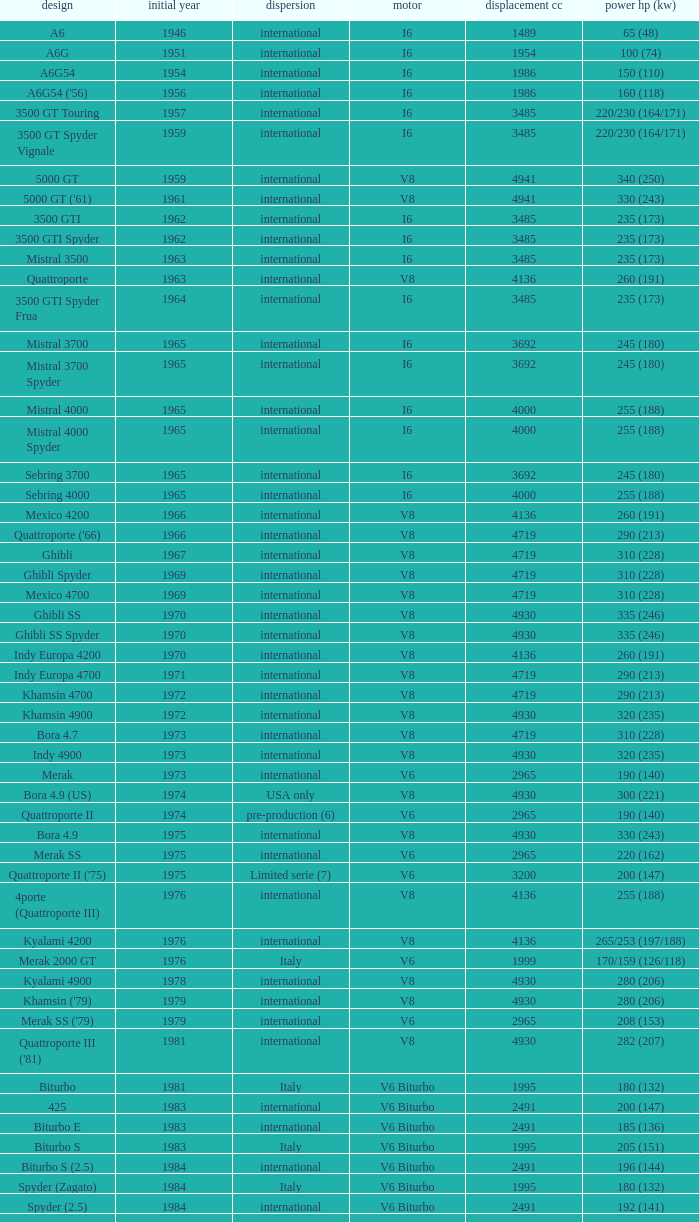Can you parse all the data within this table? {'header': ['design', 'initial year', 'dispersion', 'motor', 'displacement cc', 'power hp (kw)'], 'rows': [['A6', '1946', 'international', 'I6', '1489', '65 (48)'], ['A6G', '1951', 'international', 'I6', '1954', '100 (74)'], ['A6G54', '1954', 'international', 'I6', '1986', '150 (110)'], ["A6G54 ('56)", '1956', 'international', 'I6', '1986', '160 (118)'], ['3500 GT Touring', '1957', 'international', 'I6', '3485', '220/230 (164/171)'], ['3500 GT Spyder Vignale', '1959', 'international', 'I6', '3485', '220/230 (164/171)'], ['5000 GT', '1959', 'international', 'V8', '4941', '340 (250)'], ["5000 GT ('61)", '1961', 'international', 'V8', '4941', '330 (243)'], ['3500 GTI', '1962', 'international', 'I6', '3485', '235 (173)'], ['3500 GTI Spyder', '1962', 'international', 'I6', '3485', '235 (173)'], ['Mistral 3500', '1963', 'international', 'I6', '3485', '235 (173)'], ['Quattroporte', '1963', 'international', 'V8', '4136', '260 (191)'], ['3500 GTI Spyder Frua', '1964', 'international', 'I6', '3485', '235 (173)'], ['Mistral 3700', '1965', 'international', 'I6', '3692', '245 (180)'], ['Mistral 3700 Spyder', '1965', 'international', 'I6', '3692', '245 (180)'], ['Mistral 4000', '1965', 'international', 'I6', '4000', '255 (188)'], ['Mistral 4000 Spyder', '1965', 'international', 'I6', '4000', '255 (188)'], ['Sebring 3700', '1965', 'international', 'I6', '3692', '245 (180)'], ['Sebring 4000', '1965', 'international', 'I6', '4000', '255 (188)'], ['Mexico 4200', '1966', 'international', 'V8', '4136', '260 (191)'], ["Quattroporte ('66)", '1966', 'international', 'V8', '4719', '290 (213)'], ['Ghibli', '1967', 'international', 'V8', '4719', '310 (228)'], ['Ghibli Spyder', '1969', 'international', 'V8', '4719', '310 (228)'], ['Mexico 4700', '1969', 'international', 'V8', '4719', '310 (228)'], ['Ghibli SS', '1970', 'international', 'V8', '4930', '335 (246)'], ['Ghibli SS Spyder', '1970', 'international', 'V8', '4930', '335 (246)'], ['Indy Europa 4200', '1970', 'international', 'V8', '4136', '260 (191)'], ['Indy Europa 4700', '1971', 'international', 'V8', '4719', '290 (213)'], ['Khamsin 4700', '1972', 'international', 'V8', '4719', '290 (213)'], ['Khamsin 4900', '1972', 'international', 'V8', '4930', '320 (235)'], ['Bora 4.7', '1973', 'international', 'V8', '4719', '310 (228)'], ['Indy 4900', '1973', 'international', 'V8', '4930', '320 (235)'], ['Merak', '1973', 'international', 'V6', '2965', '190 (140)'], ['Bora 4.9 (US)', '1974', 'USA only', 'V8', '4930', '300 (221)'], ['Quattroporte II', '1974', 'pre-production (6)', 'V6', '2965', '190 (140)'], ['Bora 4.9', '1975', 'international', 'V8', '4930', '330 (243)'], ['Merak SS', '1975', 'international', 'V6', '2965', '220 (162)'], ["Quattroporte II ('75)", '1975', 'Limited serie (7)', 'V6', '3200', '200 (147)'], ['4porte (Quattroporte III)', '1976', 'international', 'V8', '4136', '255 (188)'], ['Kyalami 4200', '1976', 'international', 'V8', '4136', '265/253 (197/188)'], ['Merak 2000 GT', '1976', 'Italy', 'V6', '1999', '170/159 (126/118)'], ['Kyalami 4900', '1978', 'international', 'V8', '4930', '280 (206)'], ["Khamsin ('79)", '1979', 'international', 'V8', '4930', '280 (206)'], ["Merak SS ('79)", '1979', 'international', 'V6', '2965', '208 (153)'], ["Quattroporte III ('81)", '1981', 'international', 'V8', '4930', '282 (207)'], ['Biturbo', '1981', 'Italy', 'V6 Biturbo', '1995', '180 (132)'], ['425', '1983', 'international', 'V6 Biturbo', '2491', '200 (147)'], ['Biturbo E', '1983', 'international', 'V6 Biturbo', '2491', '185 (136)'], ['Biturbo S', '1983', 'Italy', 'V6 Biturbo', '1995', '205 (151)'], ['Biturbo S (2.5)', '1984', 'international', 'V6 Biturbo', '2491', '196 (144)'], ['Spyder (Zagato)', '1984', 'Italy', 'V6 Biturbo', '1995', '180 (132)'], ['Spyder (2.5)', '1984', 'international', 'V6 Biturbo', '2491', '192 (141)'], ['420', '1985', 'Italy', 'V6 Biturbo', '1995', '180 (132)'], ['Biturbo (II)', '1985', 'Italy', 'V6 Biturbo', '1995', '180 (132)'], ['Biturbo E (II 2.5)', '1985', 'international', 'V6 Biturbo', '2491', '185 (136)'], ['Biturbo S (II)', '1985', 'Italy', 'V6 Biturbo', '1995', '210 (154)'], ['228 (228i)', '1986', 'international', 'V6 Biturbo', '2790', '250 (184)'], ['228 (228i) Kat', '1986', 'international', 'V6 Biturbo', '2790', '225 (165)'], ['420i', '1986', 'Italy', 'V6 Biturbo', '1995', '190 (140)'], ['420 S', '1986', 'Italy', 'V6 Biturbo', '1995', '210 (154)'], ['Biturbo i', '1986', 'Italy', 'V6 Biturbo', '1995', '185 (136)'], ['Quattroporte Royale (III)', '1986', 'international', 'V8', '4930', '300 (221)'], ['Spyder i', '1986', 'international', 'V6 Biturbo', '1996', '185 (136)'], ['430', '1987', 'international', 'V6 Biturbo', '2790', '225 (165)'], ['425i', '1987', 'international', 'V6 Biturbo', '2491', '188 (138)'], ['Biturbo Si', '1987', 'Italy', 'V6 Biturbo', '1995', '220 (162)'], ['Biturbo Si (2.5)', '1987', 'international', 'V6 Biturbo', '2491', '188 (138)'], ["Spyder i ('87)", '1987', 'international', 'V6 Biturbo', '1996', '195 (143)'], ['222', '1988', 'Italy', 'V6 Biturbo', '1996', '220 (162)'], ['422', '1988', 'Italy', 'V6 Biturbo', '1996', '220 (162)'], ['2.24V', '1988', 'Italy (probably)', 'V6 Biturbo', '1996', '245 (180)'], ['222 4v', '1988', 'international', 'V6 Biturbo', '2790', '279 (205)'], ['222 E', '1988', 'international', 'V6 Biturbo', '2790', '225 (165)'], ['Karif', '1988', 'international', 'V6 Biturbo', '2790', '285 (210)'], ['Karif (kat)', '1988', 'international', 'V6 Biturbo', '2790', '248 (182)'], ['Karif (kat II)', '1988', 'international', 'V6 Biturbo', '2790', '225 (165)'], ['Spyder i (2.5)', '1988', 'international', 'V6 Biturbo', '2491', '188 (138)'], ['Spyder i (2.8)', '1989', 'international', 'V6 Biturbo', '2790', '250 (184)'], ['Spyder i (2.8, kat)', '1989', 'international', 'V6 Biturbo', '2790', '225 (165)'], ["Spyder i ('90)", '1989', 'Italy', 'V6 Biturbo', '1996', '220 (162)'], ['222 SE', '1990', 'international', 'V6 Biturbo', '2790', '250 (184)'], ['222 SE (kat)', '1990', 'international', 'V6 Biturbo', '2790', '225 (165)'], ['4.18v', '1990', 'Italy', 'V6 Biturbo', '1995', '220 (162)'], ['4.24v', '1990', 'Italy (probably)', 'V6 Biturbo', '1996', '245 (180)'], ['Shamal', '1990', 'international', 'V8 Biturbo', '3217', '326 (240)'], ['2.24v II', '1991', 'Italy', 'V6 Biturbo', '1996', '245 (180)'], ['2.24v II (kat)', '1991', 'international (probably)', 'V6 Biturbo', '1996', '240 (176)'], ['222 SR', '1991', 'international', 'V6 Biturbo', '2790', '225 (165)'], ['4.24v II (kat)', '1991', 'Italy (probably)', 'V6 Biturbo', '1996', '240 (176)'], ['430 4v', '1991', 'international', 'V6 Biturbo', '2790', '279 (205)'], ['Racing', '1991', 'Italy', 'V6 Biturbo', '1996', '283 (208)'], ['Spyder III', '1991', 'Italy', 'V6 Biturbo', '1996', '245 (180)'], ['Spyder III (2.8, kat)', '1991', 'international', 'V6 Biturbo', '2790', '225 (165)'], ['Spyder III (kat)', '1991', 'Italy', 'V6 Biturbo', '1996', '240 (176)'], ['Barchetta Stradale', '1992', 'Prototype', 'V6 Biturbo', '1996', '306 (225)'], ['Barchetta Stradale 2.8', '1992', 'Single, Conversion', 'V6 Biturbo', '2790', '284 (209)'], ['Ghibli II (2.0)', '1992', 'Italy', 'V6 Biturbo', '1996', '306 (225)'], ['Ghibli II (2.8)', '1993', 'international', 'V6 Biturbo', '2790', '284 (209)'], ['Quattroporte (2.0)', '1994', 'Italy', 'V6 Biturbo', '1996', '287 (211)'], ['Quattroporte (2.8)', '1994', 'international', 'V6 Biturbo', '2790', '284 (209)'], ['Ghibli Cup', '1995', 'international', 'V6 Biturbo', '1996', '330 (243)'], ['Quattroporte Ottocilindri', '1995', 'international', 'V8 Biturbo', '3217', '335 (246)'], ['Ghibli Primatist', '1996', 'international', 'V6 Biturbo', '1996', '306 (225)'], ['3200 GT', '1998', 'international', 'V8 Biturbo', '3217', '370 (272)'], ['Quattroporte V6 Evoluzione', '1998', 'international', 'V6 Biturbo', '2790', '284 (209)'], ['Quattroporte V8 Evoluzione', '1998', 'international', 'V8 Biturbo', '3217', '335 (246)'], ['3200 GTA', '2000', 'international', 'V8 Biturbo', '3217', '368 (271)'], ['Spyder GT', '2001', 'international', 'V8', '4244', '390 (287)'], ['Spyder CC', '2001', 'international', 'V8', '4244', '390 (287)'], ['Coupé GT', '2001', 'international', 'V8', '4244', '390 (287)'], ['Coupé CC', '2001', 'international', 'V8', '4244', '390 (287)'], ['Gran Sport', '2002', 'international', 'V8', '4244', '400 (294)'], ['Quattroporte V', '2004', 'international', 'V8', '4244', '400 (294)'], ['MC12 (aka MCC)', '2004', 'Limited', 'V12', '5998', '630 (463)'], ['GranTurismo', '2008', 'international', 'V8', '4244', '405'], ['GranCabrio', '2010', 'international', 'V8', '4691', '433']]} What is the total number of First Year, when Displacement CC is greater than 4719, when Engine is V8, when Power HP (kW) is "335 (246)", and when Model is "Ghibli SS"? 1.0. 